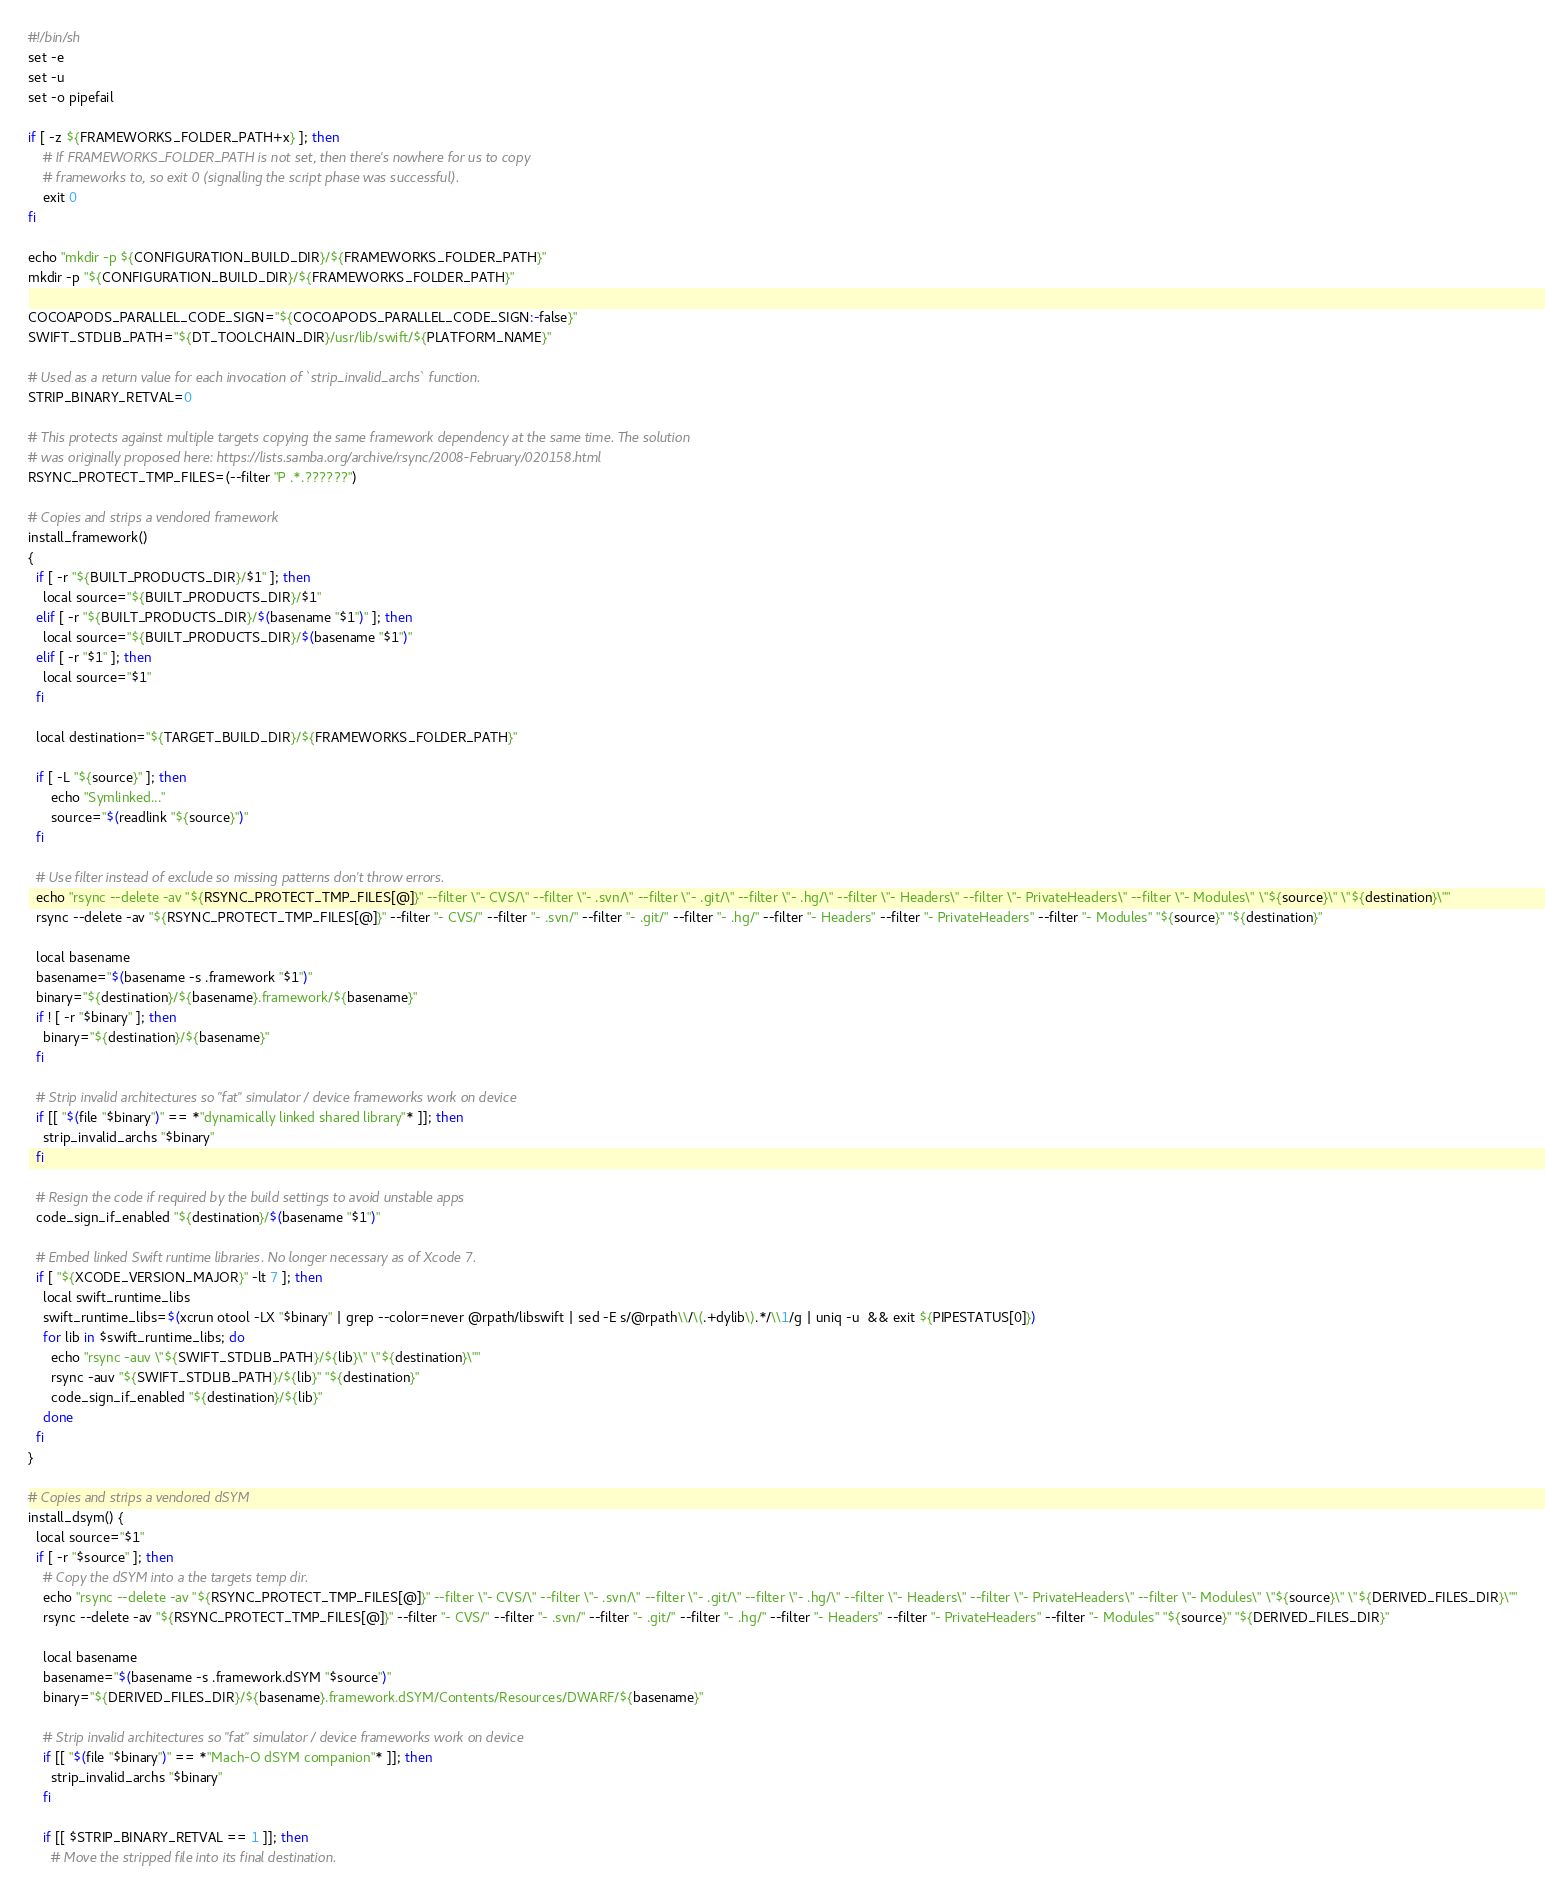<code> <loc_0><loc_0><loc_500><loc_500><_Bash_>#!/bin/sh
set -e
set -u
set -o pipefail

if [ -z ${FRAMEWORKS_FOLDER_PATH+x} ]; then
    # If FRAMEWORKS_FOLDER_PATH is not set, then there's nowhere for us to copy
    # frameworks to, so exit 0 (signalling the script phase was successful).
    exit 0
fi

echo "mkdir -p ${CONFIGURATION_BUILD_DIR}/${FRAMEWORKS_FOLDER_PATH}"
mkdir -p "${CONFIGURATION_BUILD_DIR}/${FRAMEWORKS_FOLDER_PATH}"

COCOAPODS_PARALLEL_CODE_SIGN="${COCOAPODS_PARALLEL_CODE_SIGN:-false}"
SWIFT_STDLIB_PATH="${DT_TOOLCHAIN_DIR}/usr/lib/swift/${PLATFORM_NAME}"

# Used as a return value for each invocation of `strip_invalid_archs` function.
STRIP_BINARY_RETVAL=0

# This protects against multiple targets copying the same framework dependency at the same time. The solution
# was originally proposed here: https://lists.samba.org/archive/rsync/2008-February/020158.html
RSYNC_PROTECT_TMP_FILES=(--filter "P .*.??????")

# Copies and strips a vendored framework
install_framework()
{
  if [ -r "${BUILT_PRODUCTS_DIR}/$1" ]; then
    local source="${BUILT_PRODUCTS_DIR}/$1"
  elif [ -r "${BUILT_PRODUCTS_DIR}/$(basename "$1")" ]; then
    local source="${BUILT_PRODUCTS_DIR}/$(basename "$1")"
  elif [ -r "$1" ]; then
    local source="$1"
  fi

  local destination="${TARGET_BUILD_DIR}/${FRAMEWORKS_FOLDER_PATH}"

  if [ -L "${source}" ]; then
      echo "Symlinked..."
      source="$(readlink "${source}")"
  fi

  # Use filter instead of exclude so missing patterns don't throw errors.
  echo "rsync --delete -av "${RSYNC_PROTECT_TMP_FILES[@]}" --filter \"- CVS/\" --filter \"- .svn/\" --filter \"- .git/\" --filter \"- .hg/\" --filter \"- Headers\" --filter \"- PrivateHeaders\" --filter \"- Modules\" \"${source}\" \"${destination}\""
  rsync --delete -av "${RSYNC_PROTECT_TMP_FILES[@]}" --filter "- CVS/" --filter "- .svn/" --filter "- .git/" --filter "- .hg/" --filter "- Headers" --filter "- PrivateHeaders" --filter "- Modules" "${source}" "${destination}"

  local basename
  basename="$(basename -s .framework "$1")"
  binary="${destination}/${basename}.framework/${basename}"
  if ! [ -r "$binary" ]; then
    binary="${destination}/${basename}"
  fi

  # Strip invalid architectures so "fat" simulator / device frameworks work on device
  if [[ "$(file "$binary")" == *"dynamically linked shared library"* ]]; then
    strip_invalid_archs "$binary"
  fi

  # Resign the code if required by the build settings to avoid unstable apps
  code_sign_if_enabled "${destination}/$(basename "$1")"

  # Embed linked Swift runtime libraries. No longer necessary as of Xcode 7.
  if [ "${XCODE_VERSION_MAJOR}" -lt 7 ]; then
    local swift_runtime_libs
    swift_runtime_libs=$(xcrun otool -LX "$binary" | grep --color=never @rpath/libswift | sed -E s/@rpath\\/\(.+dylib\).*/\\1/g | uniq -u  && exit ${PIPESTATUS[0]})
    for lib in $swift_runtime_libs; do
      echo "rsync -auv \"${SWIFT_STDLIB_PATH}/${lib}\" \"${destination}\""
      rsync -auv "${SWIFT_STDLIB_PATH}/${lib}" "${destination}"
      code_sign_if_enabled "${destination}/${lib}"
    done
  fi
}

# Copies and strips a vendored dSYM
install_dsym() {
  local source="$1"
  if [ -r "$source" ]; then
    # Copy the dSYM into a the targets temp dir.
    echo "rsync --delete -av "${RSYNC_PROTECT_TMP_FILES[@]}" --filter \"- CVS/\" --filter \"- .svn/\" --filter \"- .git/\" --filter \"- .hg/\" --filter \"- Headers\" --filter \"- PrivateHeaders\" --filter \"- Modules\" \"${source}\" \"${DERIVED_FILES_DIR}\""
    rsync --delete -av "${RSYNC_PROTECT_TMP_FILES[@]}" --filter "- CVS/" --filter "- .svn/" --filter "- .git/" --filter "- .hg/" --filter "- Headers" --filter "- PrivateHeaders" --filter "- Modules" "${source}" "${DERIVED_FILES_DIR}"

    local basename
    basename="$(basename -s .framework.dSYM "$source")"
    binary="${DERIVED_FILES_DIR}/${basename}.framework.dSYM/Contents/Resources/DWARF/${basename}"

    # Strip invalid architectures so "fat" simulator / device frameworks work on device
    if [[ "$(file "$binary")" == *"Mach-O dSYM companion"* ]]; then
      strip_invalid_archs "$binary"
    fi

    if [[ $STRIP_BINARY_RETVAL == 1 ]]; then
      # Move the stripped file into its final destination.</code> 